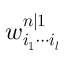<formula> <loc_0><loc_0><loc_500><loc_500>w _ { i _ { 1 } \cdots i _ { l } } ^ { n | 1 }</formula> 